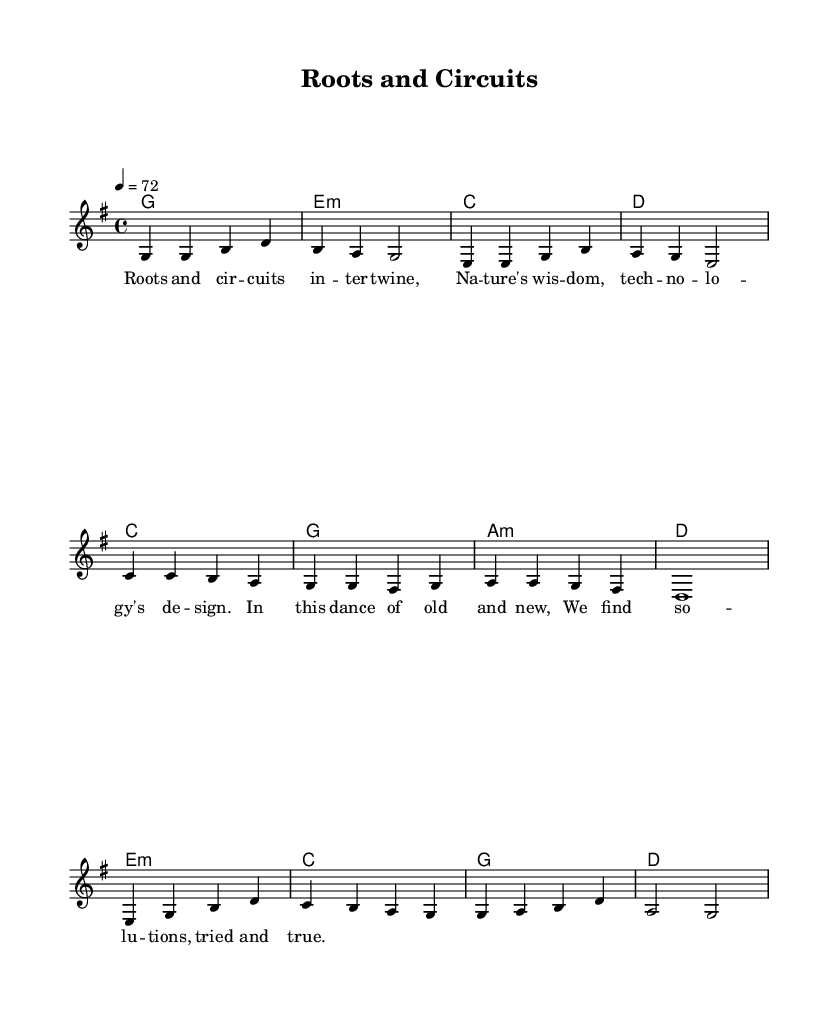What is the key signature of this music? The key signature at the beginning of the music indicates it is in G major, as shown by the symbol for one sharp (F#) in the key signature.
Answer: G major What is the time signature of this piece? The time signature displayed in the music is 4/4, as seen at the beginning of the score. This means there are four beats per measure, and each quarter note gets one beat.
Answer: 4/4 What is the tempo marking in this score? The tempo marking indicates a speed of 72 beats per minute, represented by the text '4 = 72' in the score.
Answer: 72 What is the first chord in the verse? The first chord in the verse is G major, which is represented at the beginning of the chord progression.
Answer: G How many measures are there in the verse section? The verse section contains four measures, as counted from the melody and chord sequence presented in that part.
Answer: 4 How does the chorus differ in terms of chord progression compared to the verse? The chorus contrasts with the verse by changing the chords used; specifically, it switches from a G-C-E-D progression in the verse to a C-G-Am-D progression in the chorus, showcasing a new harmonic relationship.
Answer: C-G-Am-D 